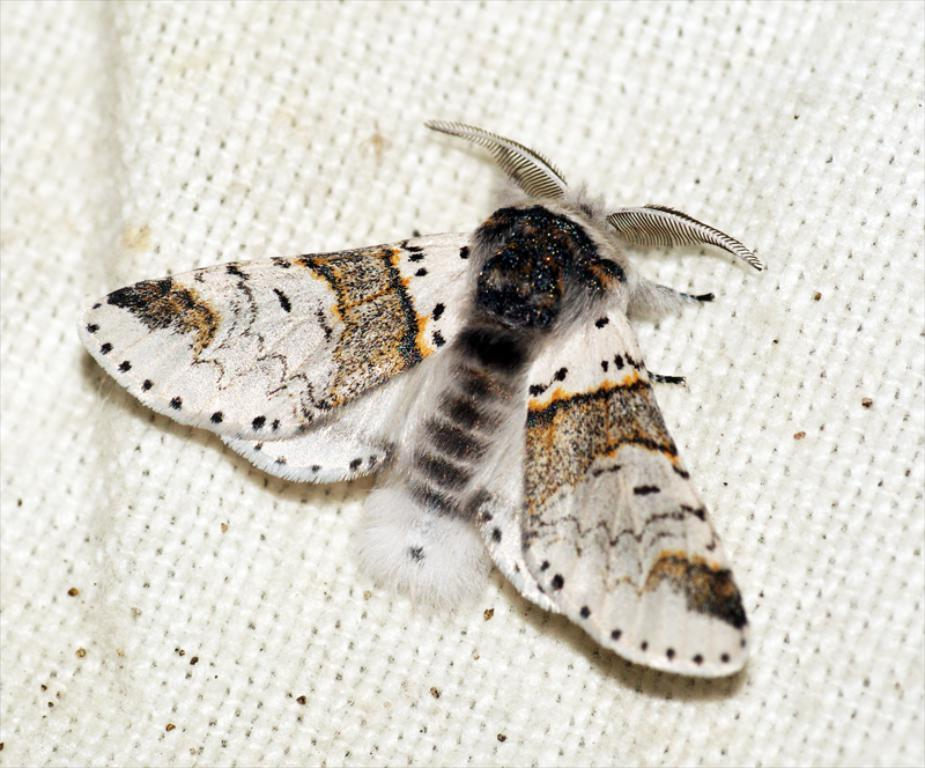What is the main subject in the center of the image? There is a fly in the center of the image. What type of material is present at the bottom of the image? There is a jute cloth at the bottom of the image. What does the caption say about the boys in the image? There is no caption or mention of boys in the image. 